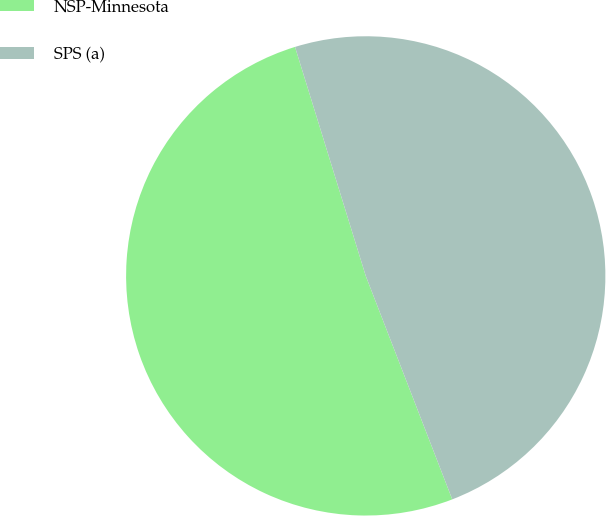Convert chart to OTSL. <chart><loc_0><loc_0><loc_500><loc_500><pie_chart><fcel>NSP-Minnesota<fcel>SPS (a)<nl><fcel>51.11%<fcel>48.89%<nl></chart> 